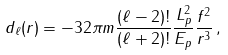Convert formula to latex. <formula><loc_0><loc_0><loc_500><loc_500>d _ { \ell } ( r ) = - 3 2 \pi m \frac { ( \ell - 2 ) ! } { ( \ell + 2 ) ! } \frac { L ^ { 2 } _ { p } } { E _ { p } } \frac { f ^ { 2 } } { r ^ { 3 } } \, ,</formula> 